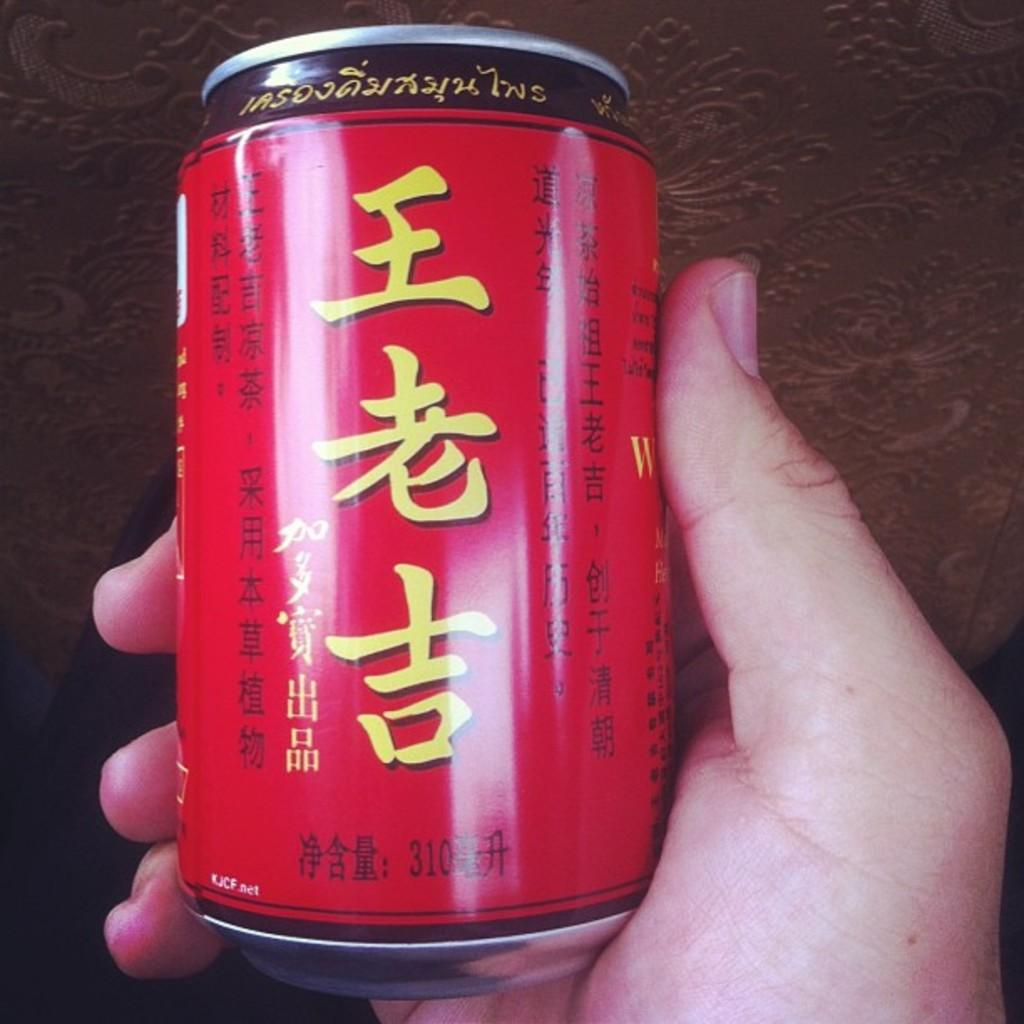<image>
Create a compact narrative representing the image presented. A hand is holding a red beverage can with the KJCF.net url on it. 